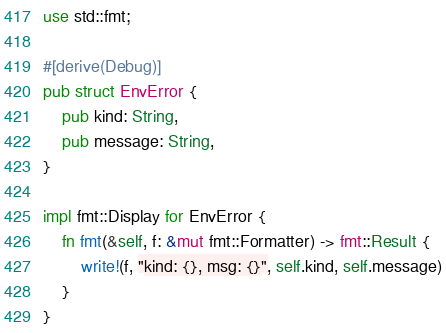Convert code to text. <code><loc_0><loc_0><loc_500><loc_500><_Rust_>use std::fmt;

#[derive(Debug)]
pub struct EnvError {
    pub kind: String,
    pub message: String,
}

impl fmt::Display for EnvError {
    fn fmt(&self, f: &mut fmt::Formatter) -> fmt::Result {
        write!(f, "kind: {}, msg: {}", self.kind, self.message)
    }
}
</code> 